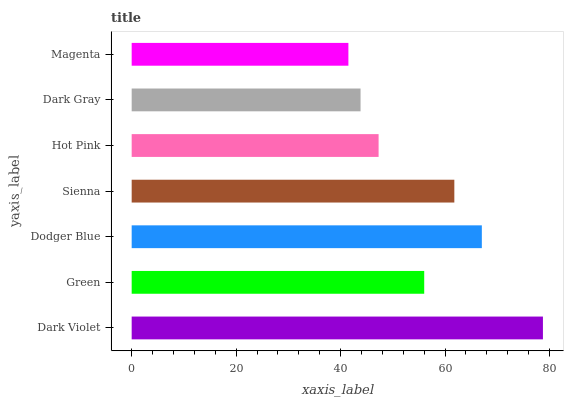Is Magenta the minimum?
Answer yes or no. Yes. Is Dark Violet the maximum?
Answer yes or no. Yes. Is Green the minimum?
Answer yes or no. No. Is Green the maximum?
Answer yes or no. No. Is Dark Violet greater than Green?
Answer yes or no. Yes. Is Green less than Dark Violet?
Answer yes or no. Yes. Is Green greater than Dark Violet?
Answer yes or no. No. Is Dark Violet less than Green?
Answer yes or no. No. Is Green the high median?
Answer yes or no. Yes. Is Green the low median?
Answer yes or no. Yes. Is Dodger Blue the high median?
Answer yes or no. No. Is Dark Violet the low median?
Answer yes or no. No. 